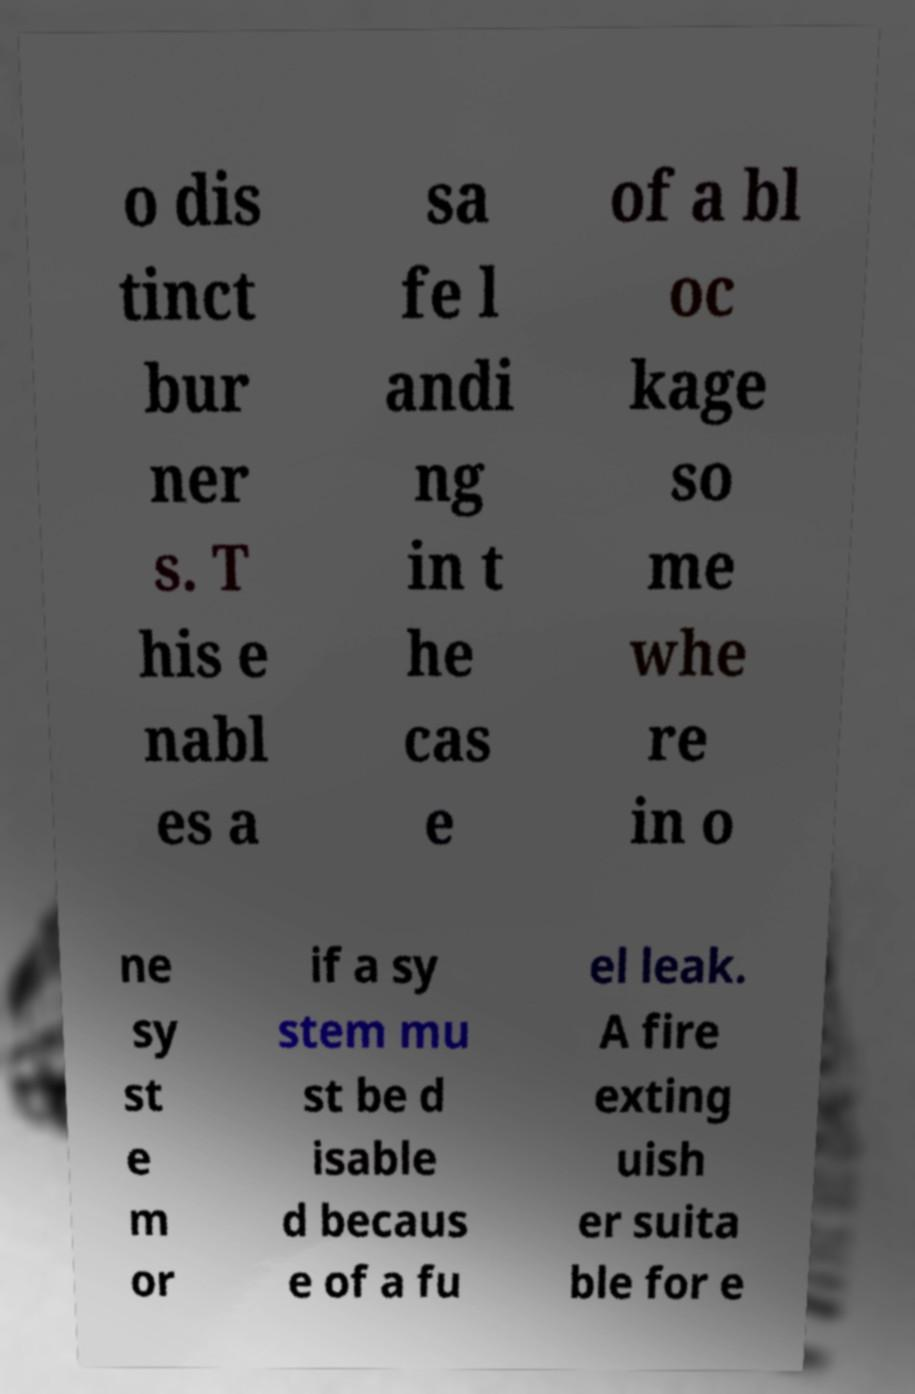What messages or text are displayed in this image? I need them in a readable, typed format. o dis tinct bur ner s. T his e nabl es a sa fe l andi ng in t he cas e of a bl oc kage so me whe re in o ne sy st e m or if a sy stem mu st be d isable d becaus e of a fu el leak. A fire exting uish er suita ble for e 